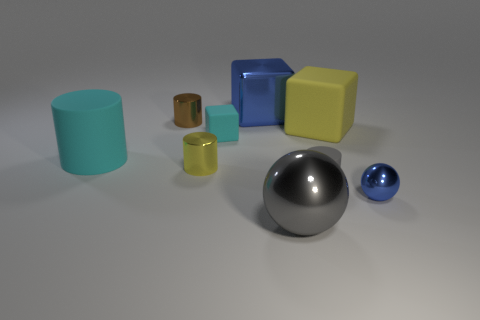There is a ball that is the same color as the large metal block; what is it made of?
Your response must be concise. Metal. What number of blocks have the same color as the large cylinder?
Provide a succinct answer. 1. There is a small cylinder that is made of the same material as the yellow cube; what color is it?
Provide a short and direct response. Gray. Is there a yellow rubber block that has the same size as the gray shiny sphere?
Your answer should be compact. Yes. What is the shape of the cyan thing that is the same size as the blue ball?
Your answer should be compact. Cube. Are there any other matte objects of the same shape as the small gray object?
Ensure brevity in your answer.  Yes. Do the large gray sphere and the large object that is on the right side of the small rubber cylinder have the same material?
Make the answer very short. No. Are there any metal blocks of the same color as the small ball?
Offer a very short reply. Yes. What number of other objects are there of the same material as the small yellow thing?
Your answer should be compact. 4. Do the tiny shiny sphere and the large object in front of the big cyan thing have the same color?
Ensure brevity in your answer.  No. 